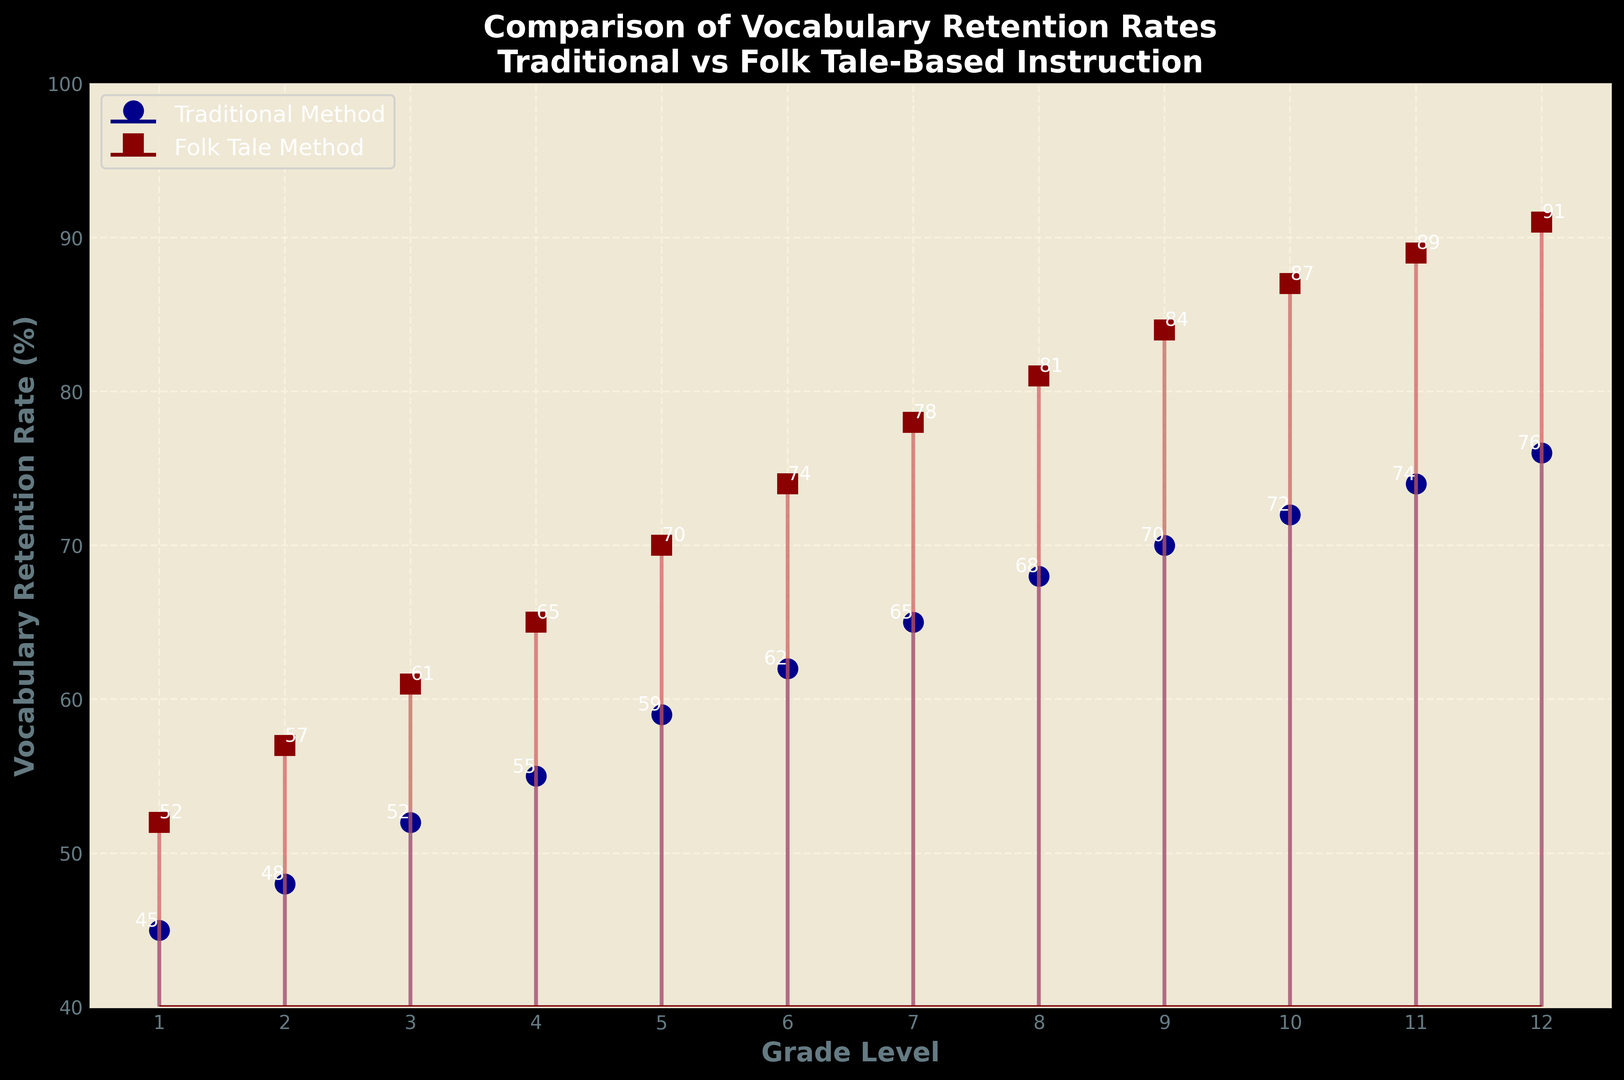What grade level shows the highest vocabulary retention rate using the Folk Tale Method? The figure shows that Grade 12 has the highest value for the Folk Tale Method, which is 91%.
Answer: Grade 12 Which teaching method shows a higher retention rate for Grade 5, and by how much? Grade 5 retention rates are 59% for Traditional Method and 70% for Folk Tale Method. The Folk Tale Method is higher by 70% - 59% = 11%.
Answer: Folk Tale Method by 11% What is the average retention rate for the Traditional Method across all grades? To find the average, sum the retention rates (45+48+52+55+59+62+65+68+70+72+74+76) = 746, then divide by the number of grades, 12. Average = 746/12 = 62.17%.
Answer: 62.17% How does the retention rate change from Grade 1 to Grade 12 for the Folk Tale Method? Retention rate for Folk Tale Method at Grade 1 is 52%, and at Grade 12 it is 91%. The change is 91% - 52% = 39%.
Answer: Increases by 39% In which grade does the difference in retention rates between the two methods peak, and what is the value of this difference? Calculate the differences for each grade and find the maximum. Differences: 7, 9, 9, 10, 11, 12, 13, 13, 14, 15, 15, 15. The maximum difference is 15 in Grades 10, 11, and 12.
Answer: Grade 10, 11, 12, by 15% What is the overall trend observed as grade levels increase for both teaching methods? Both methods show an increasing trend in vocabulary retention rates as grade levels increase.
Answer: Increasing trend At which grade level do both teaching methods have the same difference in retention rate, and what is that difference? Calculate differences: Grade 1 (7), Grade 2 (9), Grade 3 (9), Grade 4 (10), Grade 5 (11), Grade 6 (12), Grade 7 (13), Grade 8 (13), Grade 9 (14), Grade 10 (15), Grade 11 (15), Grade 12 (15). Equal differences are seen at Grades 2 and 3, 7 and 8, 10, 11, 12.
Answer: Grades 2 and 3 (9), Grades 7 and 8 (13), Grades 10, 11, and 12 (15) 